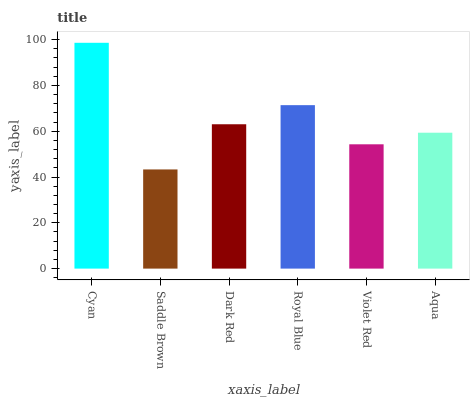Is Saddle Brown the minimum?
Answer yes or no. Yes. Is Cyan the maximum?
Answer yes or no. Yes. Is Dark Red the minimum?
Answer yes or no. No. Is Dark Red the maximum?
Answer yes or no. No. Is Dark Red greater than Saddle Brown?
Answer yes or no. Yes. Is Saddle Brown less than Dark Red?
Answer yes or no. Yes. Is Saddle Brown greater than Dark Red?
Answer yes or no. No. Is Dark Red less than Saddle Brown?
Answer yes or no. No. Is Dark Red the high median?
Answer yes or no. Yes. Is Aqua the low median?
Answer yes or no. Yes. Is Violet Red the high median?
Answer yes or no. No. Is Cyan the low median?
Answer yes or no. No. 